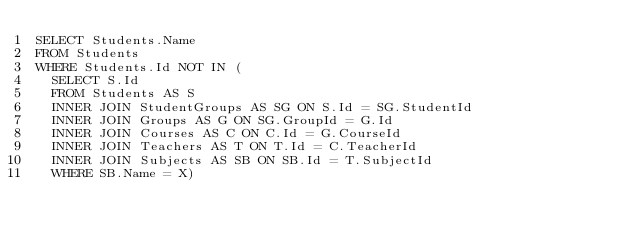Convert code to text. <code><loc_0><loc_0><loc_500><loc_500><_SQL_>SELECT Students.Name 
FROM Students
WHERE Students.Id NOT IN (
	SELECT S.Id
	FROM Students AS S 
	INNER JOIN StudentGroups AS SG ON S.Id = SG.StudentId 
	INNER JOIN Groups AS G ON SG.GroupId = G.Id 
	INNER JOIN Courses AS C ON C.Id = G.CourseId
	INNER JOIN Teachers AS T ON T.Id = C.TeacherId
	INNER JOIN Subjects AS SB ON SB.Id = T.SubjectId
	WHERE SB.Name = X)</code> 